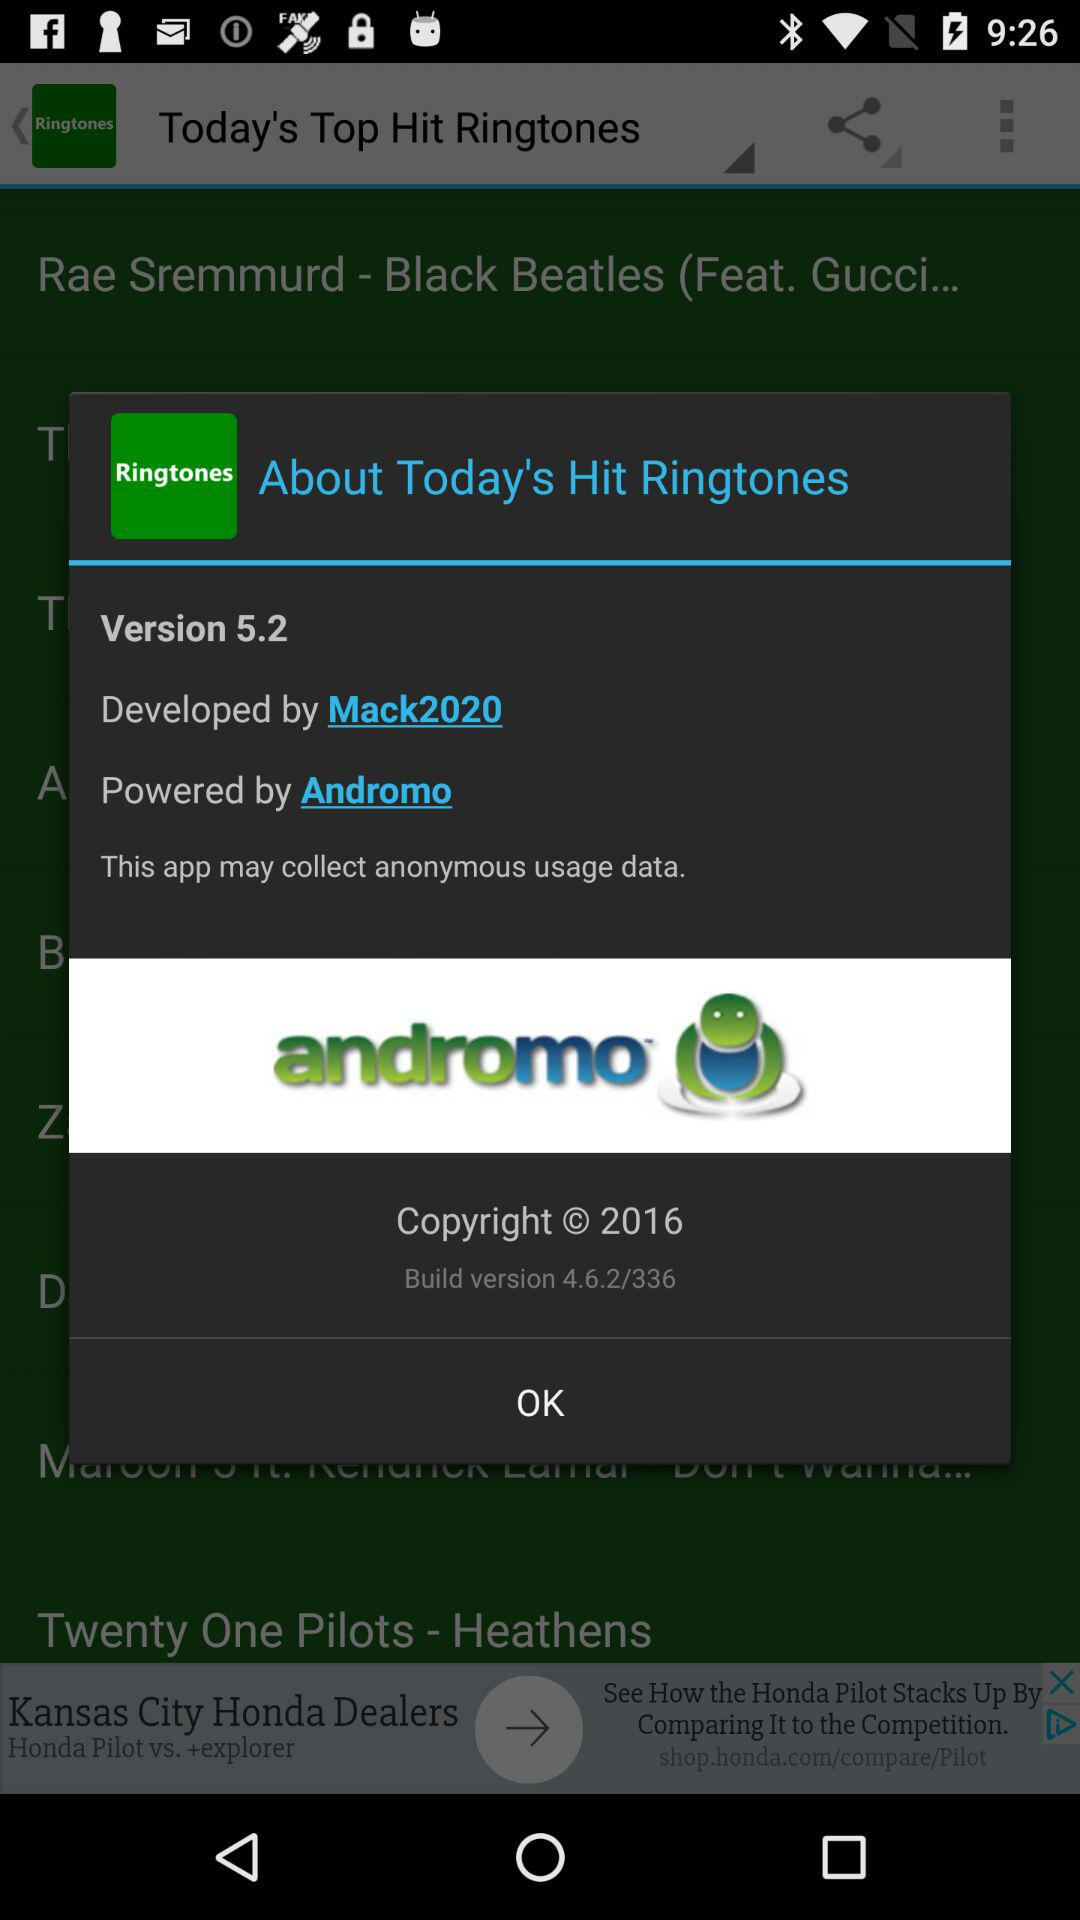By whom was the application powered? The application was powered by "Andromo". 